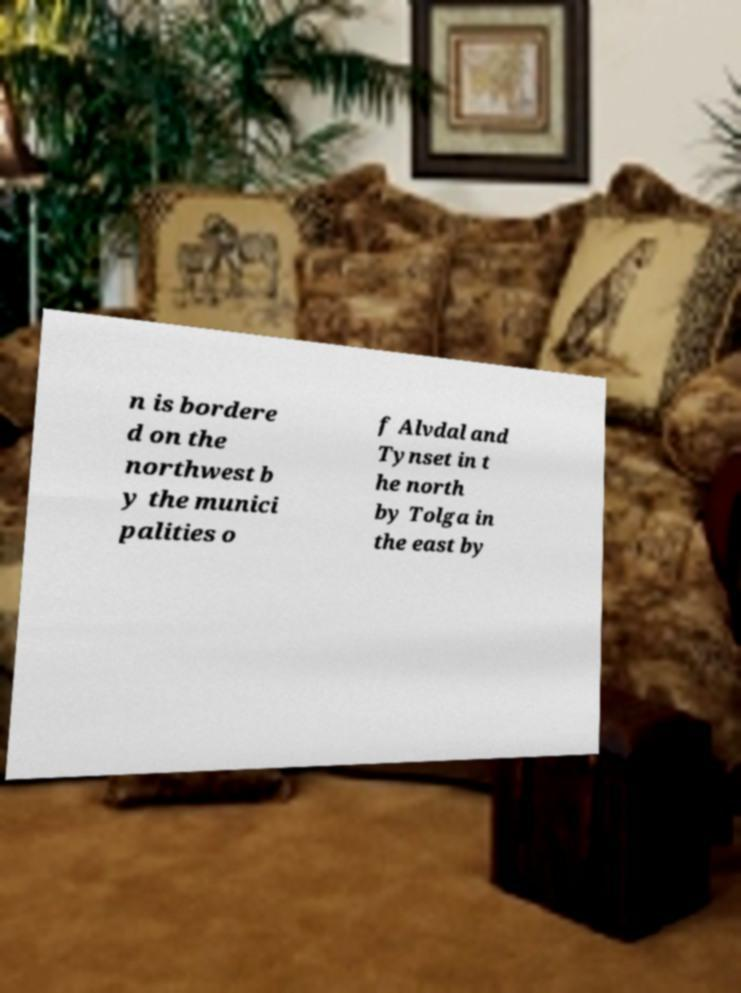For documentation purposes, I need the text within this image transcribed. Could you provide that? n is bordere d on the northwest b y the munici palities o f Alvdal and Tynset in t he north by Tolga in the east by 